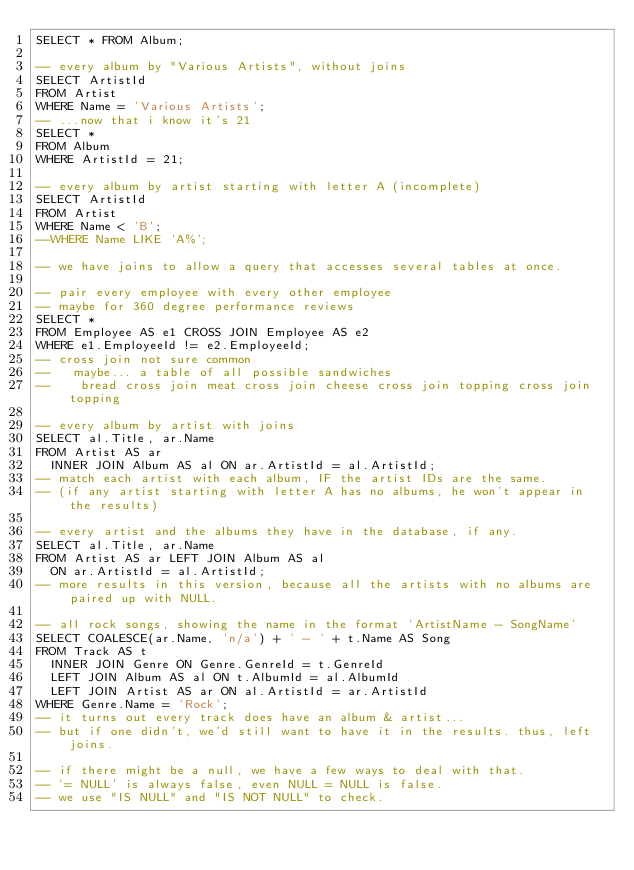<code> <loc_0><loc_0><loc_500><loc_500><_SQL_>SELECT * FROM Album;

-- every album by "Various Artists", without joins
SELECT ArtistId
FROM Artist
WHERE Name = 'Various Artists';
-- ...now that i know it's 21
SELECT *
FROM Album
WHERE ArtistId = 21;

-- every album by artist starting with letter A (incomplete)
SELECT ArtistId
FROM Artist
WHERE Name < 'B';
--WHERE Name LIKE 'A%';

-- we have joins to allow a query that accesses several tables at once.

-- pair every employee with every other employee
-- maybe for 360 degree performance reviews
SELECT *
FROM Employee AS e1 CROSS JOIN Employee AS e2
WHERE e1.EmployeeId != e2.EmployeeId;
-- cross join not sure common
--   maybe... a table of all possible sandwiches
--    bread cross join meat cross join cheese cross join topping cross join topping

-- every album by artist with joins
SELECT al.Title, ar.Name
FROM Artist AS ar
	INNER JOIN Album AS al ON ar.ArtistId = al.ArtistId;
-- match each artist with each album, IF the artist IDs are the same.
-- (if any artist starting with letter A has no albums, he won't appear in the results)

-- every artist and the albums they have in the database, if any.
SELECT al.Title, ar.Name
FROM Artist AS ar LEFT JOIN Album AS al
	ON ar.ArtistId = al.ArtistId;
-- more results in this version, because all the artists with no albums are paired up with NULL.

-- all rock songs, showing the name in the format 'ArtistName - SongName'
SELECT COALESCE(ar.Name, 'n/a') + ' - ' + t.Name AS Song
FROM Track AS t
	INNER JOIN Genre ON Genre.GenreId = t.GenreId
	LEFT JOIN Album AS al ON t.AlbumId = al.AlbumId
	LEFT JOIN Artist AS ar ON al.ArtistId = ar.ArtistId
WHERE Genre.Name = 'Rock';
-- it turns out every track does have an album & artist...
-- but if one didn't, we'd still want to have it in the results. thus, left joins.

-- if there might be a null, we have a few ways to deal with that.
-- '= NULL' is always false, even NULL = NULL is false.
-- we use "IS NULL" and "IS NOT NULL" to check.</code> 